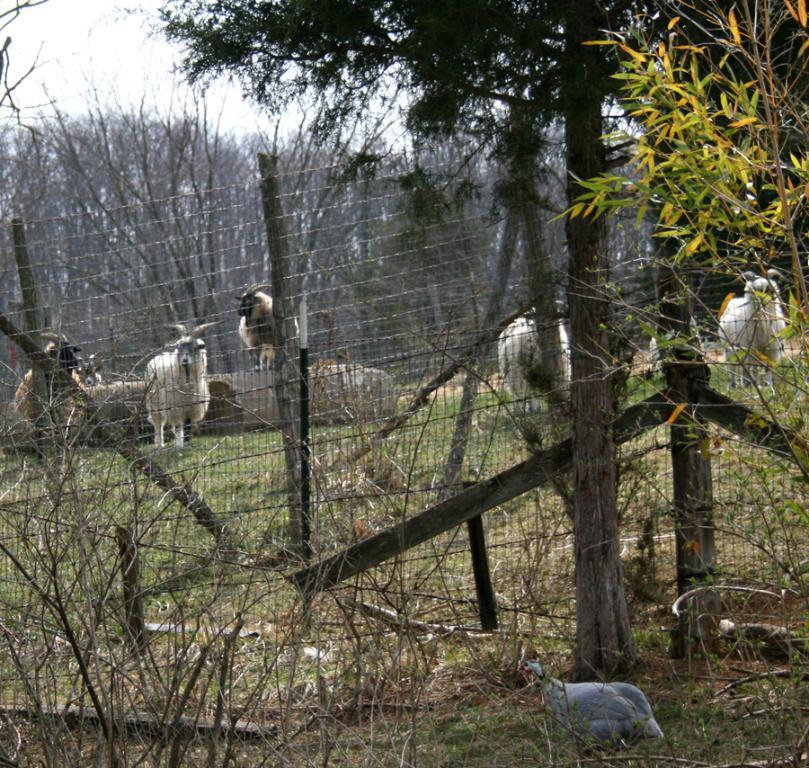What types of animals can be seen in the image? There are herds of animals in the image. What other living creatures are present in the image? There are birds in the image. What can be seen under the animals' feet in the image? The ground is visible in the image. What separates the animals from the surrounding area? There is a fence in the image. What type of vegetation is present in the image? Grass is present in the image. What else can be seen in the background of the image? There are trees in the image. What part of the natural environment is visible in the image? The sky is visible in the image. Based on the presence of sunlight, when do you think the image was taken? The image was likely taken during the day. What type of soap is being used to clean the animals in the image? There is no soap or cleaning activity depicted in the image; it shows herds of animals and birds in their natural environment. 